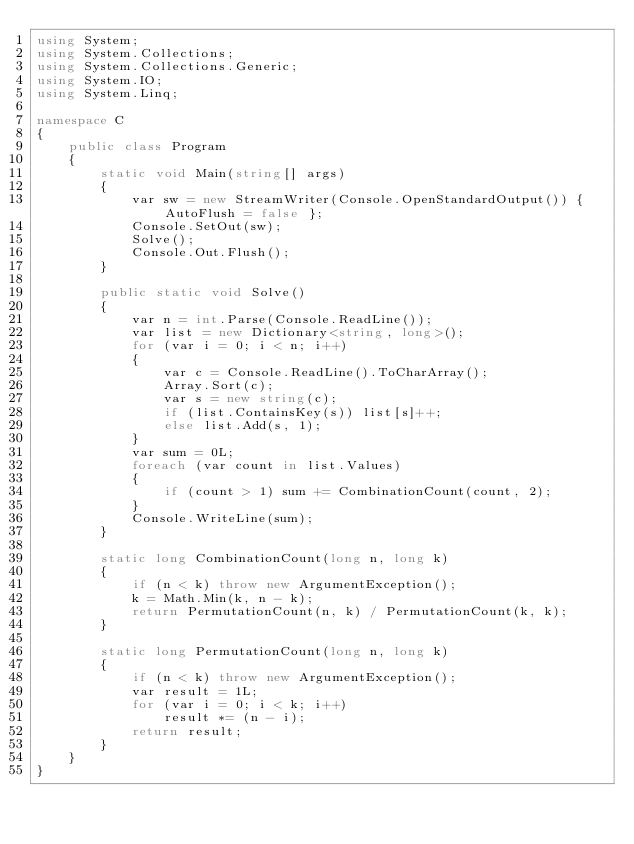Convert code to text. <code><loc_0><loc_0><loc_500><loc_500><_C#_>using System;
using System.Collections;
using System.Collections.Generic;
using System.IO;
using System.Linq;

namespace C
{
    public class Program
    {
        static void Main(string[] args)
        {
            var sw = new StreamWriter(Console.OpenStandardOutput()) { AutoFlush = false };
            Console.SetOut(sw);
            Solve();
            Console.Out.Flush();
        }

        public static void Solve()
        {
            var n = int.Parse(Console.ReadLine());
            var list = new Dictionary<string, long>();
            for (var i = 0; i < n; i++)
            {
                var c = Console.ReadLine().ToCharArray();
                Array.Sort(c);
                var s = new string(c);
                if (list.ContainsKey(s)) list[s]++;
                else list.Add(s, 1);
            }
            var sum = 0L;
            foreach (var count in list.Values)
            {
                if (count > 1) sum += CombinationCount(count, 2);
            }
            Console.WriteLine(sum);
        }

        static long CombinationCount(long n, long k)
        {
            if (n < k) throw new ArgumentException();
            k = Math.Min(k, n - k);
            return PermutationCount(n, k) / PermutationCount(k, k);
        }

        static long PermutationCount(long n, long k)
        {
            if (n < k) throw new ArgumentException();
            var result = 1L;
            for (var i = 0; i < k; i++)
                result *= (n - i);
            return result;
        }
    }
}
</code> 